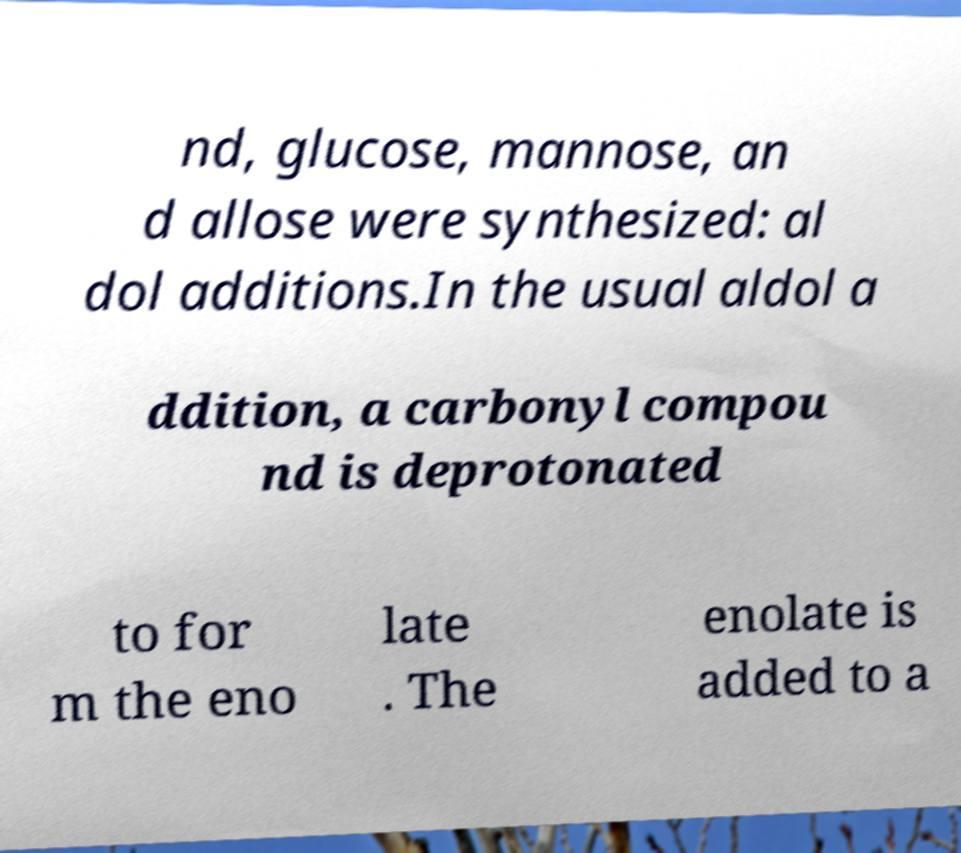I need the written content from this picture converted into text. Can you do that? nd, glucose, mannose, an d allose were synthesized: al dol additions.In the usual aldol a ddition, a carbonyl compou nd is deprotonated to for m the eno late . The enolate is added to a 